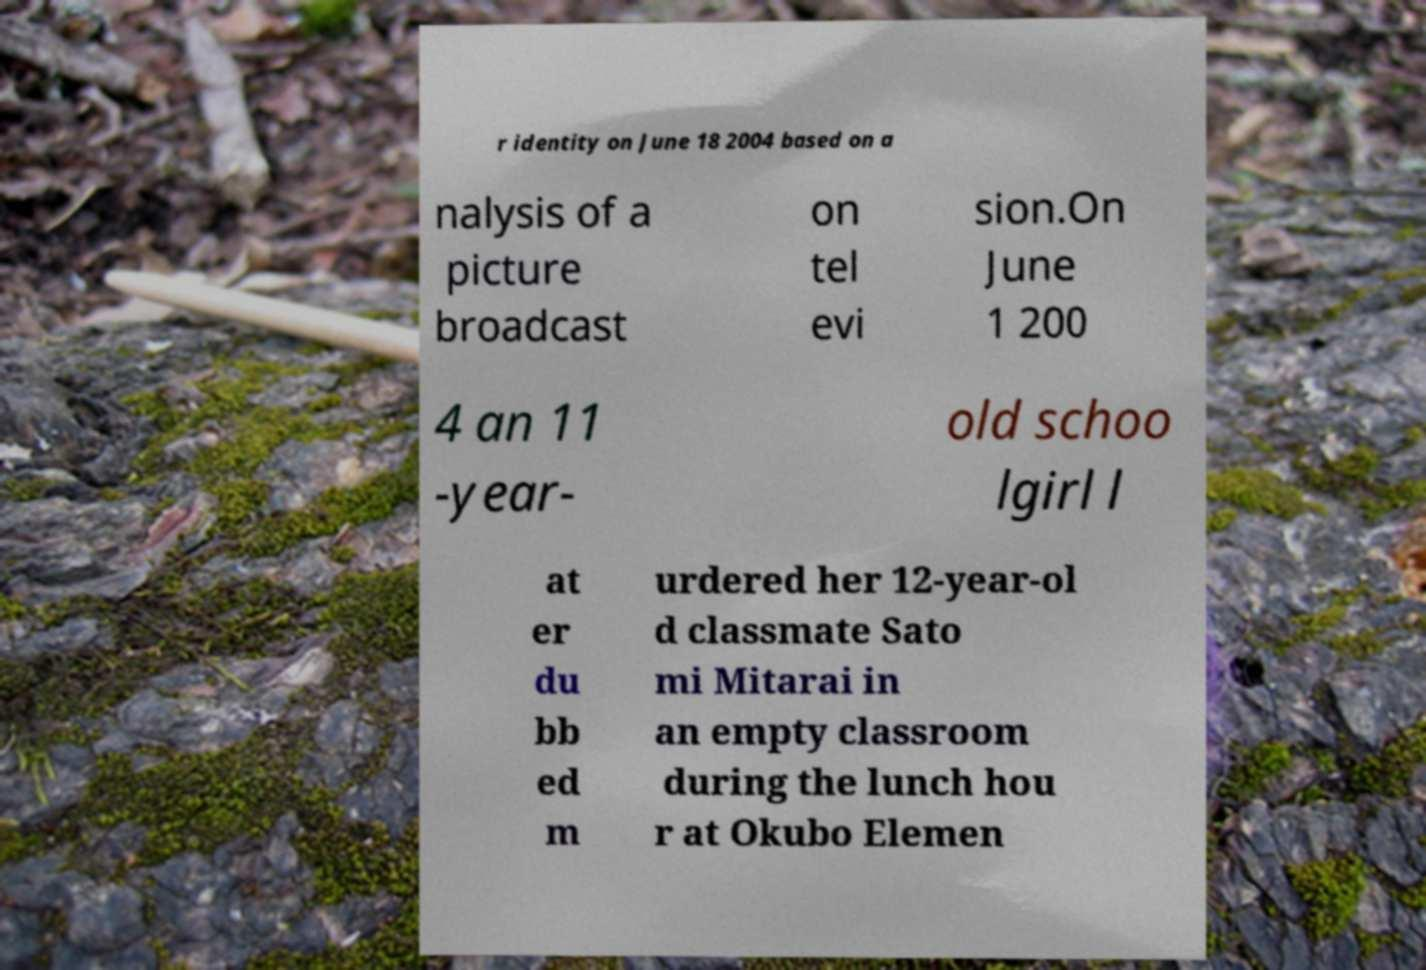Please identify and transcribe the text found in this image. r identity on June 18 2004 based on a nalysis of a picture broadcast on tel evi sion.On June 1 200 4 an 11 -year- old schoo lgirl l at er du bb ed m urdered her 12-year-ol d classmate Sato mi Mitarai in an empty classroom during the lunch hou r at Okubo Elemen 